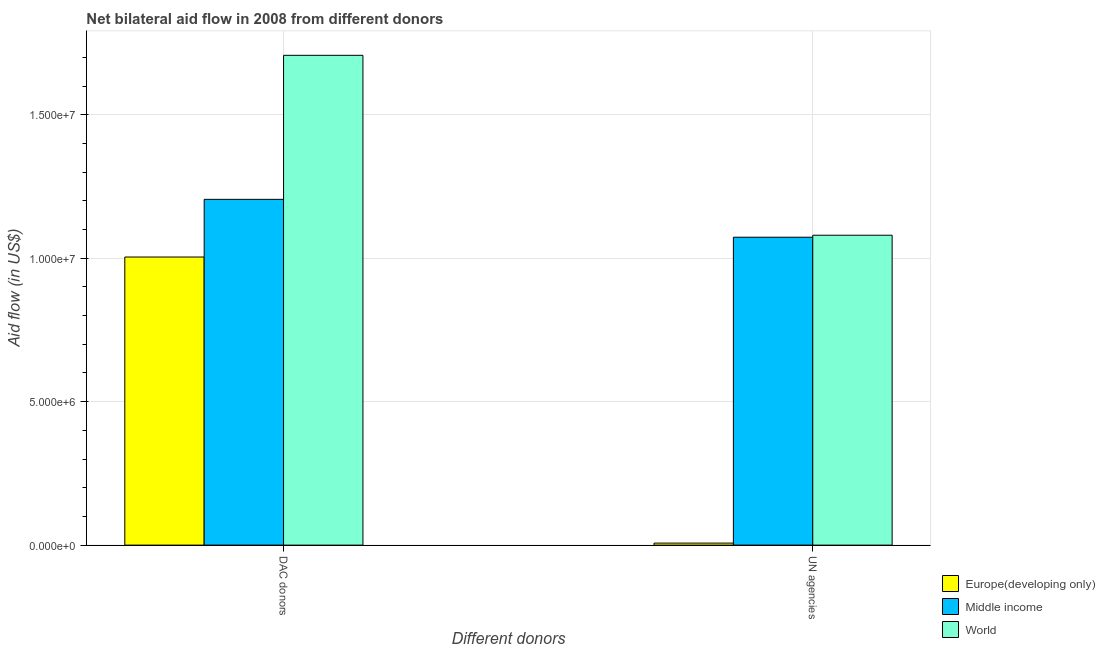How many different coloured bars are there?
Make the answer very short. 3. Are the number of bars on each tick of the X-axis equal?
Give a very brief answer. Yes. How many bars are there on the 1st tick from the left?
Offer a terse response. 3. How many bars are there on the 1st tick from the right?
Offer a terse response. 3. What is the label of the 1st group of bars from the left?
Your answer should be compact. DAC donors. What is the aid flow from dac donors in Europe(developing only)?
Offer a very short reply. 1.00e+07. Across all countries, what is the maximum aid flow from dac donors?
Your answer should be very brief. 1.71e+07. Across all countries, what is the minimum aid flow from dac donors?
Make the answer very short. 1.00e+07. In which country was the aid flow from un agencies minimum?
Offer a very short reply. Europe(developing only). What is the total aid flow from dac donors in the graph?
Your answer should be compact. 3.92e+07. What is the difference between the aid flow from dac donors in Middle income and that in World?
Provide a succinct answer. -5.02e+06. What is the difference between the aid flow from un agencies in Europe(developing only) and the aid flow from dac donors in Middle income?
Your response must be concise. -1.20e+07. What is the average aid flow from dac donors per country?
Your response must be concise. 1.31e+07. What is the difference between the aid flow from un agencies and aid flow from dac donors in Europe(developing only)?
Provide a succinct answer. -9.97e+06. What is the ratio of the aid flow from un agencies in World to that in Middle income?
Ensure brevity in your answer.  1.01. In how many countries, is the aid flow from dac donors greater than the average aid flow from dac donors taken over all countries?
Your response must be concise. 1. What does the 3rd bar from the left in UN agencies represents?
Your answer should be compact. World. How many bars are there?
Keep it short and to the point. 6. What is the difference between two consecutive major ticks on the Y-axis?
Give a very brief answer. 5.00e+06. Does the graph contain any zero values?
Ensure brevity in your answer.  No. Does the graph contain grids?
Your answer should be compact. Yes. Where does the legend appear in the graph?
Your answer should be very brief. Bottom right. How are the legend labels stacked?
Your response must be concise. Vertical. What is the title of the graph?
Ensure brevity in your answer.  Net bilateral aid flow in 2008 from different donors. What is the label or title of the X-axis?
Your answer should be very brief. Different donors. What is the label or title of the Y-axis?
Your answer should be compact. Aid flow (in US$). What is the Aid flow (in US$) in Europe(developing only) in DAC donors?
Keep it short and to the point. 1.00e+07. What is the Aid flow (in US$) of Middle income in DAC donors?
Offer a very short reply. 1.20e+07. What is the Aid flow (in US$) of World in DAC donors?
Offer a very short reply. 1.71e+07. What is the Aid flow (in US$) in Middle income in UN agencies?
Keep it short and to the point. 1.07e+07. What is the Aid flow (in US$) of World in UN agencies?
Your answer should be very brief. 1.08e+07. Across all Different donors, what is the maximum Aid flow (in US$) in Europe(developing only)?
Provide a succinct answer. 1.00e+07. Across all Different donors, what is the maximum Aid flow (in US$) in Middle income?
Provide a short and direct response. 1.20e+07. Across all Different donors, what is the maximum Aid flow (in US$) in World?
Your answer should be compact. 1.71e+07. Across all Different donors, what is the minimum Aid flow (in US$) in Europe(developing only)?
Offer a very short reply. 7.00e+04. Across all Different donors, what is the minimum Aid flow (in US$) of Middle income?
Ensure brevity in your answer.  1.07e+07. Across all Different donors, what is the minimum Aid flow (in US$) in World?
Keep it short and to the point. 1.08e+07. What is the total Aid flow (in US$) of Europe(developing only) in the graph?
Provide a short and direct response. 1.01e+07. What is the total Aid flow (in US$) of Middle income in the graph?
Offer a very short reply. 2.28e+07. What is the total Aid flow (in US$) of World in the graph?
Offer a terse response. 2.79e+07. What is the difference between the Aid flow (in US$) of Europe(developing only) in DAC donors and that in UN agencies?
Offer a very short reply. 9.97e+06. What is the difference between the Aid flow (in US$) of Middle income in DAC donors and that in UN agencies?
Provide a succinct answer. 1.32e+06. What is the difference between the Aid flow (in US$) of World in DAC donors and that in UN agencies?
Your response must be concise. 6.27e+06. What is the difference between the Aid flow (in US$) in Europe(developing only) in DAC donors and the Aid flow (in US$) in Middle income in UN agencies?
Keep it short and to the point. -6.90e+05. What is the difference between the Aid flow (in US$) in Europe(developing only) in DAC donors and the Aid flow (in US$) in World in UN agencies?
Offer a very short reply. -7.60e+05. What is the difference between the Aid flow (in US$) of Middle income in DAC donors and the Aid flow (in US$) of World in UN agencies?
Provide a short and direct response. 1.25e+06. What is the average Aid flow (in US$) in Europe(developing only) per Different donors?
Your answer should be compact. 5.06e+06. What is the average Aid flow (in US$) in Middle income per Different donors?
Your answer should be compact. 1.14e+07. What is the average Aid flow (in US$) of World per Different donors?
Provide a succinct answer. 1.39e+07. What is the difference between the Aid flow (in US$) of Europe(developing only) and Aid flow (in US$) of Middle income in DAC donors?
Give a very brief answer. -2.01e+06. What is the difference between the Aid flow (in US$) of Europe(developing only) and Aid flow (in US$) of World in DAC donors?
Your response must be concise. -7.03e+06. What is the difference between the Aid flow (in US$) of Middle income and Aid flow (in US$) of World in DAC donors?
Ensure brevity in your answer.  -5.02e+06. What is the difference between the Aid flow (in US$) in Europe(developing only) and Aid flow (in US$) in Middle income in UN agencies?
Your response must be concise. -1.07e+07. What is the difference between the Aid flow (in US$) of Europe(developing only) and Aid flow (in US$) of World in UN agencies?
Provide a short and direct response. -1.07e+07. What is the difference between the Aid flow (in US$) in Middle income and Aid flow (in US$) in World in UN agencies?
Ensure brevity in your answer.  -7.00e+04. What is the ratio of the Aid flow (in US$) of Europe(developing only) in DAC donors to that in UN agencies?
Your answer should be very brief. 143.43. What is the ratio of the Aid flow (in US$) of Middle income in DAC donors to that in UN agencies?
Provide a succinct answer. 1.12. What is the ratio of the Aid flow (in US$) in World in DAC donors to that in UN agencies?
Your answer should be compact. 1.58. What is the difference between the highest and the second highest Aid flow (in US$) in Europe(developing only)?
Give a very brief answer. 9.97e+06. What is the difference between the highest and the second highest Aid flow (in US$) in Middle income?
Ensure brevity in your answer.  1.32e+06. What is the difference between the highest and the second highest Aid flow (in US$) of World?
Keep it short and to the point. 6.27e+06. What is the difference between the highest and the lowest Aid flow (in US$) of Europe(developing only)?
Give a very brief answer. 9.97e+06. What is the difference between the highest and the lowest Aid flow (in US$) in Middle income?
Your response must be concise. 1.32e+06. What is the difference between the highest and the lowest Aid flow (in US$) in World?
Your answer should be compact. 6.27e+06. 